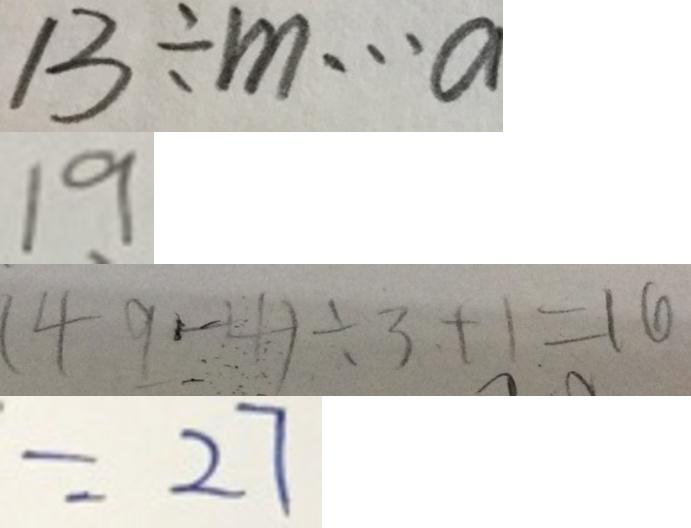Convert formula to latex. <formula><loc_0><loc_0><loc_500><loc_500>1 3 \div m \cdots a 
 1 9 
 ( 4 9 - 4 ) \div 3 + 1 = 1 6 
 = 2 7</formula> 